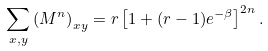<formula> <loc_0><loc_0><loc_500><loc_500>\sum _ { x , y } { ( M ^ { n } ) } _ { x y } = r \left [ 1 + ( r - 1 ) e ^ { - \beta } \right ] ^ { 2 n } .</formula> 